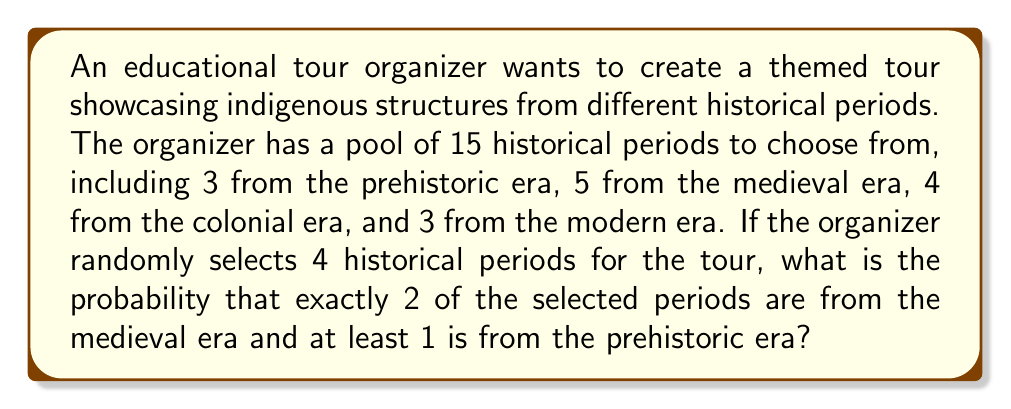Can you solve this math problem? Let's approach this step-by-step:

1) First, we need to calculate the total number of ways to select 4 periods out of 15:
   $$\binom{15}{4} = \frac{15!}{4!(15-4)!} = 1365$$

2) Now, we need to calculate the number of favorable outcomes. We can break this down:
   - We need exactly 2 from medieval era (5 choices)
   - At least 1 from prehistoric era (3 choices)
   - The remaining can be from any other era except medieval

3) Let's calculate this in two parts:
   a) 2 medieval, 1 prehistoric, 1 from others:
      $$\binom{5}{2} \cdot \binom{3}{1} \cdot \binom{7}{1} = 10 \cdot 3 \cdot 7 = 210$$
   
   b) 2 medieval, 2 prehistoric:
      $$\binom{5}{2} \cdot \binom{3}{2} = 10 \cdot 3 = 30$$

4) Total favorable outcomes: 210 + 30 = 240

5) The probability is therefore:
   $$P = \frac{240}{1365} = \frac{16}{91} \approx 0.1758$$
Answer: $\frac{16}{91}$ 